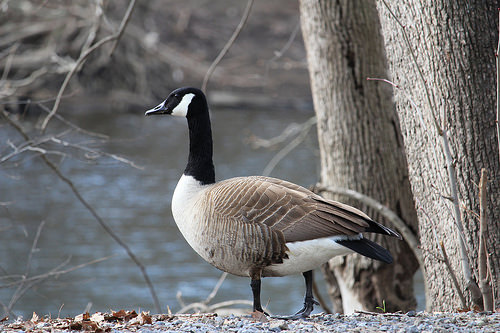<image>
Is the goose in the water? No. The goose is not contained within the water. These objects have a different spatial relationship. 